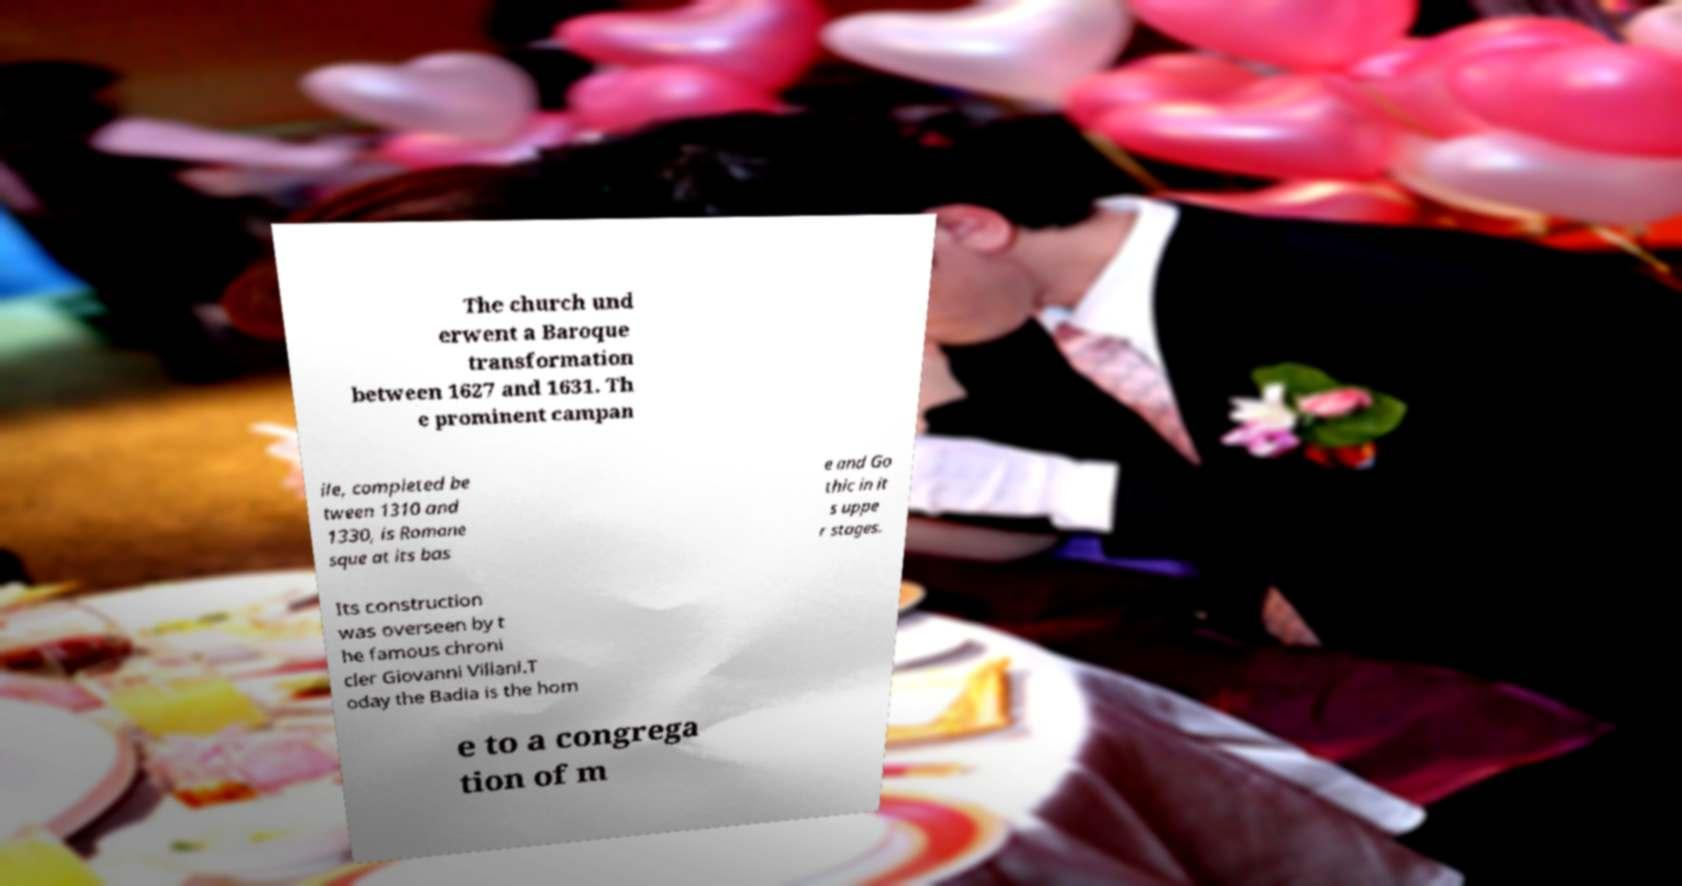Please identify and transcribe the text found in this image. The church und erwent a Baroque transformation between 1627 and 1631. Th e prominent campan ile, completed be tween 1310 and 1330, is Romane sque at its bas e and Go thic in it s uppe r stages. Its construction was overseen by t he famous chroni cler Giovanni Villani.T oday the Badia is the hom e to a congrega tion of m 